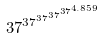<formula> <loc_0><loc_0><loc_500><loc_500>3 7 ^ { 3 7 ^ { 3 7 ^ { 3 7 ^ { 3 7 ^ { 4 . 8 5 9 } } } } }</formula> 